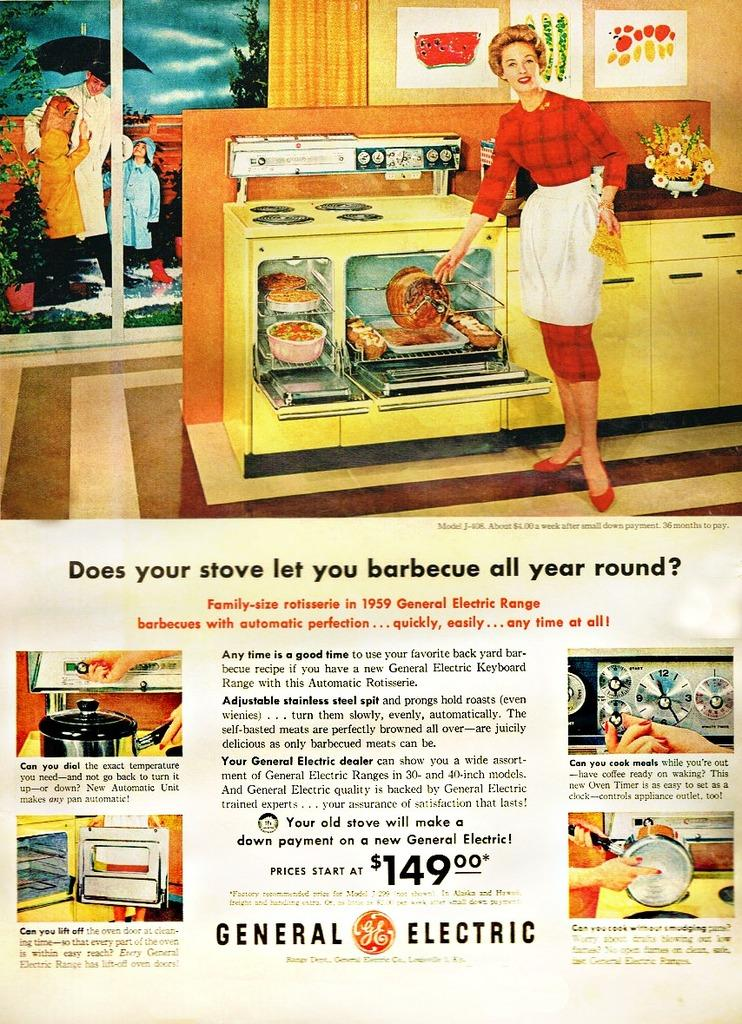<image>
Summarize the visual content of the image. old advertisement for 1959 general electric stove with a price starting at $149.00 